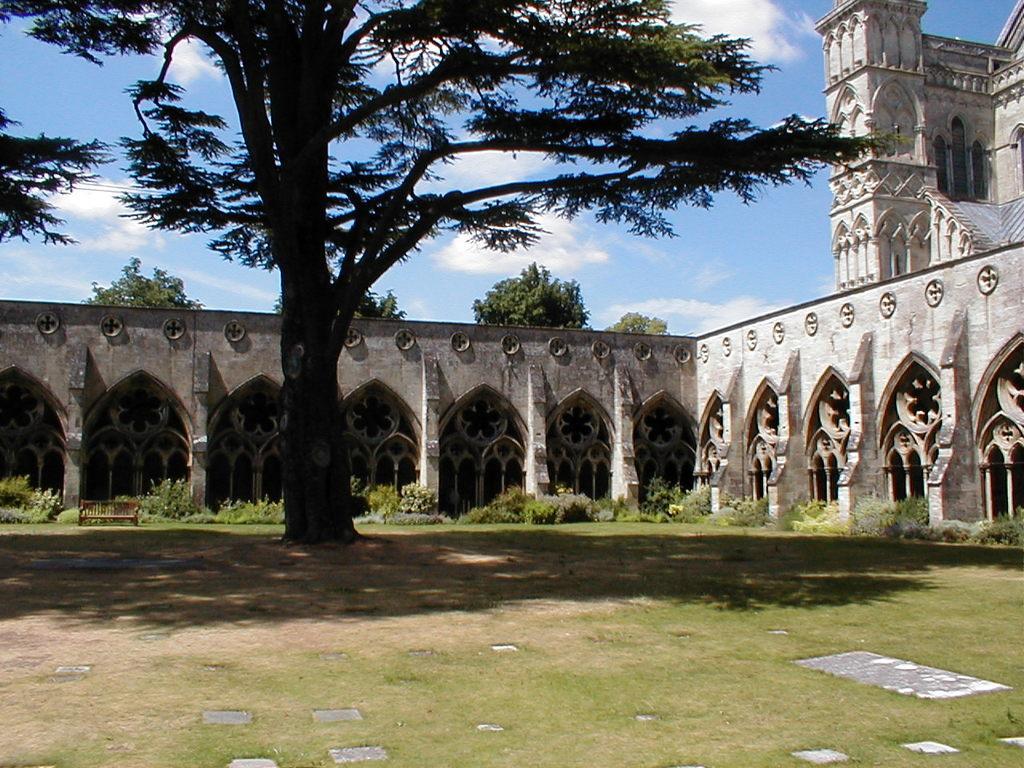In one or two sentences, can you explain what this image depicts? In this picture we can see grass, tree, ground, pillars and building. In the background of the image we can see trees and sky with clouds. 